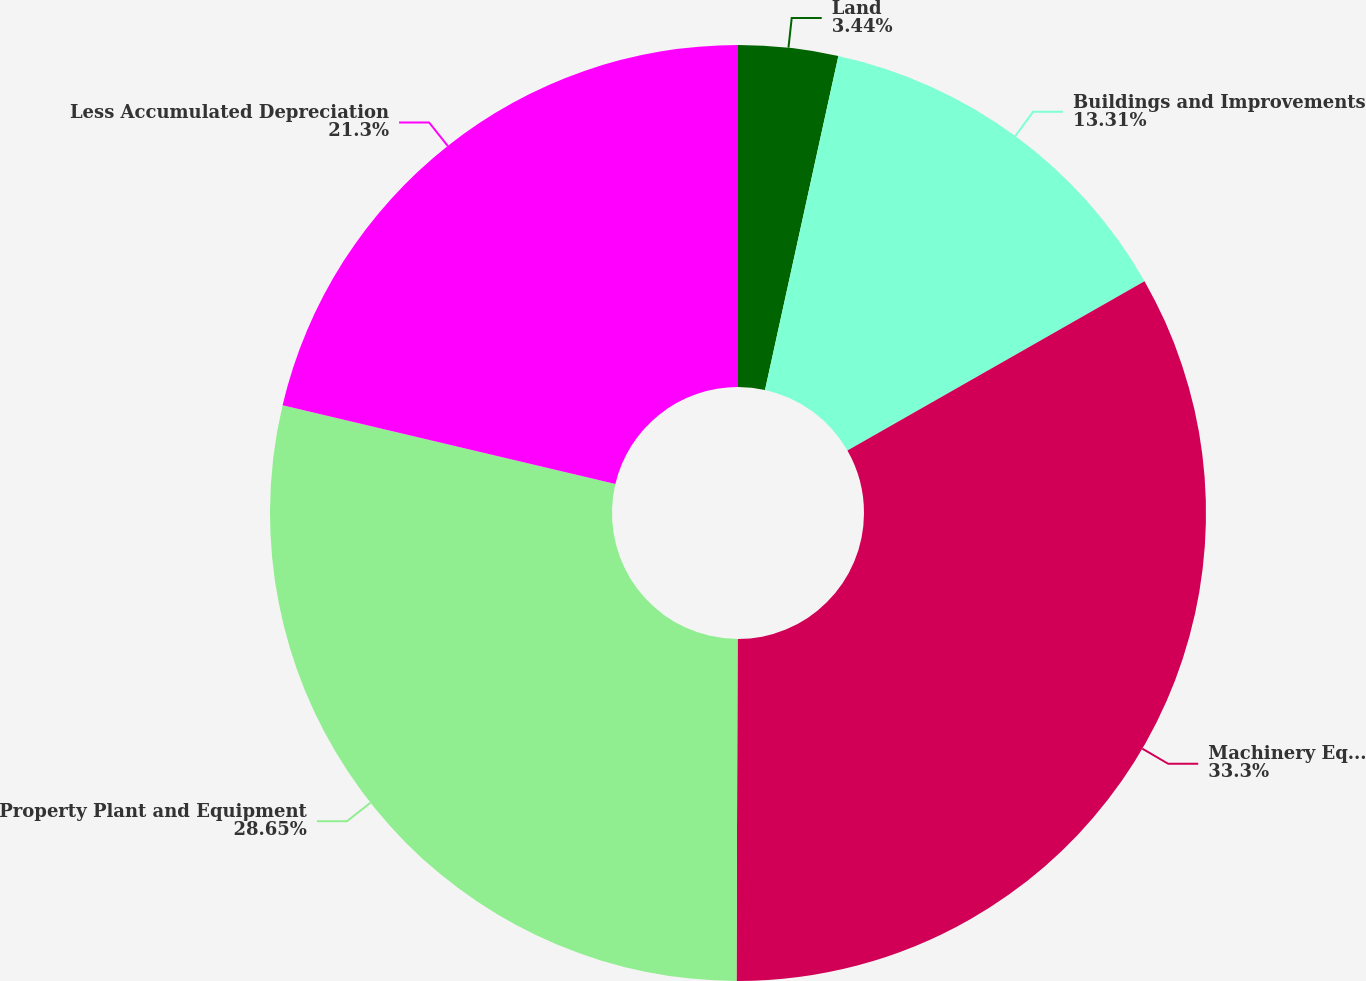Convert chart to OTSL. <chart><loc_0><loc_0><loc_500><loc_500><pie_chart><fcel>Land<fcel>Buildings and Improvements<fcel>Machinery Equipment and<fcel>Property Plant and Equipment<fcel>Less Accumulated Depreciation<nl><fcel>3.44%<fcel>13.31%<fcel>33.3%<fcel>28.65%<fcel>21.3%<nl></chart> 